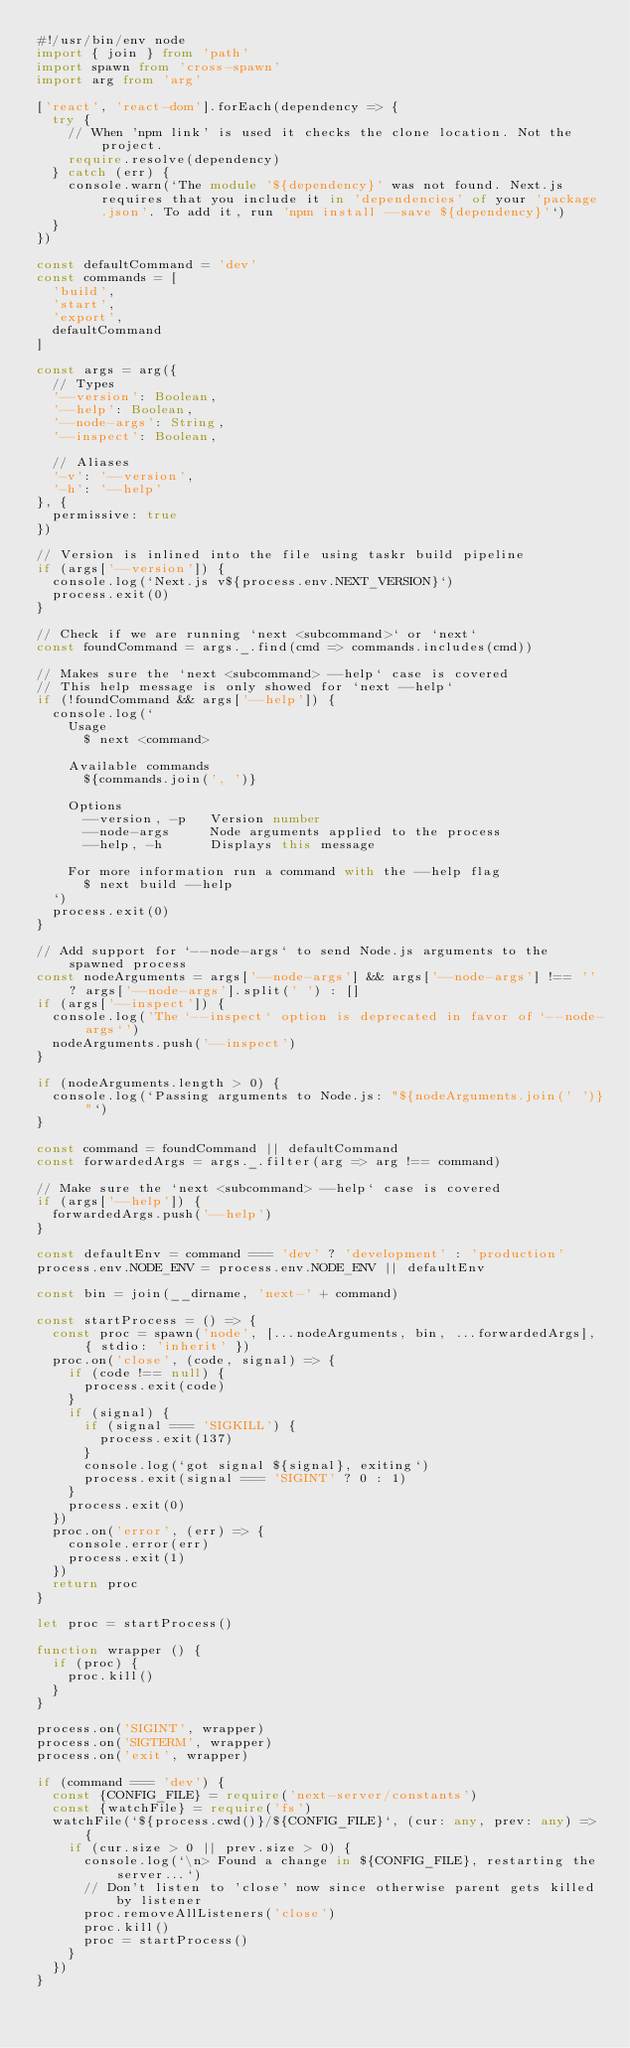Convert code to text. <code><loc_0><loc_0><loc_500><loc_500><_TypeScript_>#!/usr/bin/env node
import { join } from 'path'
import spawn from 'cross-spawn'
import arg from 'arg'

['react', 'react-dom'].forEach(dependency => {
  try {
    // When 'npm link' is used it checks the clone location. Not the project.
    require.resolve(dependency)
  } catch (err) {
    console.warn(`The module '${dependency}' was not found. Next.js requires that you include it in 'dependencies' of your 'package.json'. To add it, run 'npm install --save ${dependency}'`)
  }
})

const defaultCommand = 'dev'
const commands = [
  'build',
  'start',
  'export',
  defaultCommand
]

const args = arg({
  // Types
  '--version': Boolean,
  '--help': Boolean,
  '--node-args': String,
  '--inspect': Boolean,

  // Aliases
  '-v': '--version',
  '-h': '--help'
}, {
  permissive: true
})

// Version is inlined into the file using taskr build pipeline
if (args['--version']) {
  console.log(`Next.js v${process.env.NEXT_VERSION}`)
  process.exit(0)
}

// Check if we are running `next <subcommand>` or `next`
const foundCommand = args._.find(cmd => commands.includes(cmd))

// Makes sure the `next <subcommand> --help` case is covered
// This help message is only showed for `next --help`
if (!foundCommand && args['--help']) {
  console.log(`
    Usage
      $ next <command>

    Available commands
      ${commands.join(', ')}
      
    Options
      --version, -p   Version number
      --node-args     Node arguments applied to the process
      --help, -h      Displays this message  

    For more information run a command with the --help flag
      $ next build --help
  `)
  process.exit(0)
}

// Add support for `--node-args` to send Node.js arguments to the spawned process
const nodeArguments = args['--node-args'] && args['--node-args'] !== '' ? args['--node-args'].split(' ') : []
if (args['--inspect']) {
  console.log('The `--inspect` option is deprecated in favor of `--node-args`')
  nodeArguments.push('--inspect')
}

if (nodeArguments.length > 0) {
  console.log(`Passing arguments to Node.js: "${nodeArguments.join(' ')}"`)
}

const command = foundCommand || defaultCommand
const forwardedArgs = args._.filter(arg => arg !== command)

// Make sure the `next <subcommand> --help` case is covered
if (args['--help']) {
  forwardedArgs.push('--help')
}

const defaultEnv = command === 'dev' ? 'development' : 'production'
process.env.NODE_ENV = process.env.NODE_ENV || defaultEnv

const bin = join(__dirname, 'next-' + command)

const startProcess = () => {
  const proc = spawn('node', [...nodeArguments, bin, ...forwardedArgs], { stdio: 'inherit' })
  proc.on('close', (code, signal) => {
    if (code !== null) {
      process.exit(code)
    }
    if (signal) {
      if (signal === 'SIGKILL') {
        process.exit(137)
      }
      console.log(`got signal ${signal}, exiting`)
      process.exit(signal === 'SIGINT' ? 0 : 1)
    }
    process.exit(0)
  })
  proc.on('error', (err) => {
    console.error(err)
    process.exit(1)
  })
  return proc
}

let proc = startProcess()

function wrapper () {
  if (proc) {
    proc.kill()
  }
}

process.on('SIGINT', wrapper)
process.on('SIGTERM', wrapper)
process.on('exit', wrapper)

if (command === 'dev') {
  const {CONFIG_FILE} = require('next-server/constants')
  const {watchFile} = require('fs')
  watchFile(`${process.cwd()}/${CONFIG_FILE}`, (cur: any, prev: any) => {
    if (cur.size > 0 || prev.size > 0) {
      console.log(`\n> Found a change in ${CONFIG_FILE}, restarting the server...`)
      // Don't listen to 'close' now since otherwise parent gets killed by listener
      proc.removeAllListeners('close')
      proc.kill()
      proc = startProcess()
    }
  })
}
</code> 